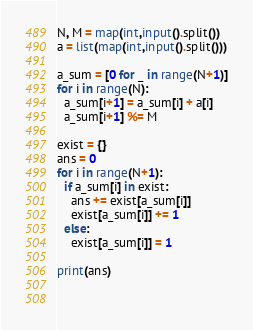Convert code to text. <code><loc_0><loc_0><loc_500><loc_500><_Python_>N, M = map(int,input().split())
a = list(map(int,input().split()))

a_sum = [0 for _ in range(N+1)]
for i in range(N):
  a_sum[i+1] = a_sum[i] + a[i]
  a_sum[i+1] %= M

exist = {}
ans = 0
for i in range(N+1):
  if a_sum[i] in exist:
    ans += exist[a_sum[i]]
    exist[a_sum[i]] += 1
  else:
    exist[a_sum[i]] = 1
    
print(ans)
  
  </code> 